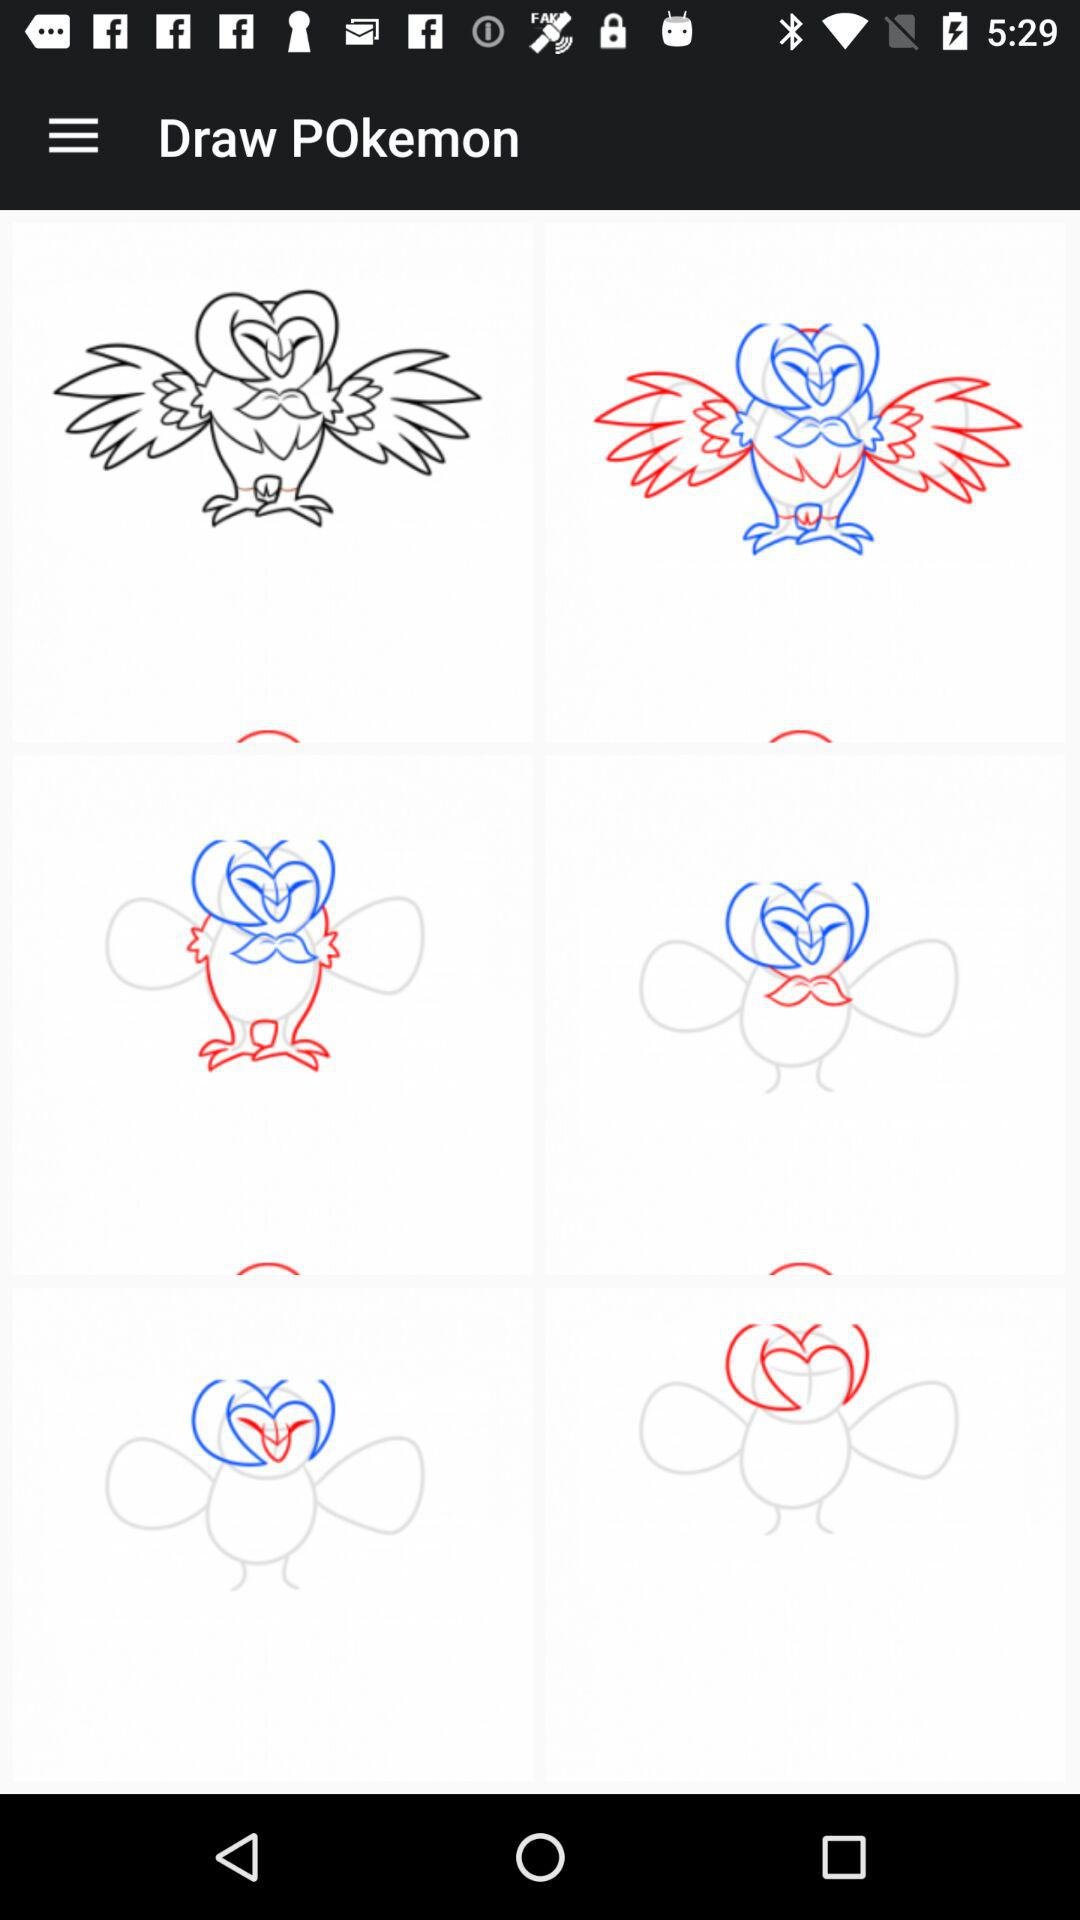How many owl drawings are on the screen?
Answer the question using a single word or phrase. 6 